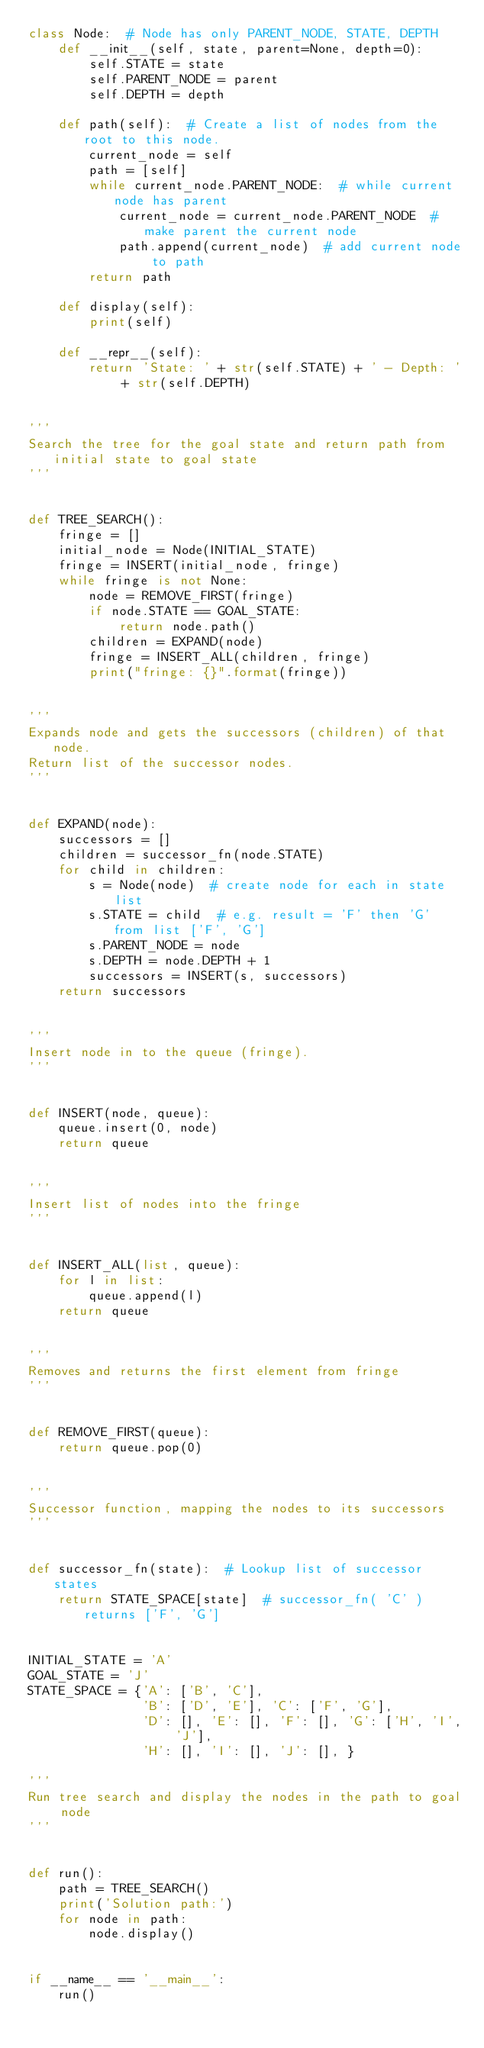Convert code to text. <code><loc_0><loc_0><loc_500><loc_500><_Python_>class Node:  # Node has only PARENT_NODE, STATE, DEPTH
    def __init__(self, state, parent=None, depth=0):
        self.STATE = state
        self.PARENT_NODE = parent
        self.DEPTH = depth

    def path(self):  # Create a list of nodes from the root to this node.
        current_node = self
        path = [self]
        while current_node.PARENT_NODE:  # while current node has parent
            current_node = current_node.PARENT_NODE  # make parent the current node
            path.append(current_node)  # add current node to path
        return path

    def display(self):
        print(self)

    def __repr__(self):
        return 'State: ' + str(self.STATE) + ' - Depth: ' + str(self.DEPTH)


'''
Search the tree for the goal state and return path from initial state to goal state
'''


def TREE_SEARCH():
    fringe = []
    initial_node = Node(INITIAL_STATE)
    fringe = INSERT(initial_node, fringe)
    while fringe is not None:
        node = REMOVE_FIRST(fringe)
        if node.STATE == GOAL_STATE:
            return node.path()
        children = EXPAND(node)
        fringe = INSERT_ALL(children, fringe)
        print("fringe: {}".format(fringe))


'''
Expands node and gets the successors (children) of that node.
Return list of the successor nodes.
'''


def EXPAND(node):
    successors = []
    children = successor_fn(node.STATE)
    for child in children:
        s = Node(node)  # create node for each in state list
        s.STATE = child  # e.g. result = 'F' then 'G' from list ['F', 'G']
        s.PARENT_NODE = node
        s.DEPTH = node.DEPTH + 1
        successors = INSERT(s, successors)
    return successors


'''
Insert node in to the queue (fringe).
'''


def INSERT(node, queue):
    queue.insert(0, node)
    return queue


'''
Insert list of nodes into the fringe
'''


def INSERT_ALL(list, queue):
    for l in list:
        queue.append(l)
    return queue


'''
Removes and returns the first element from fringe
'''


def REMOVE_FIRST(queue):
    return queue.pop(0)


'''
Successor function, mapping the nodes to its successors
'''


def successor_fn(state):  # Lookup list of successor states
    return STATE_SPACE[state]  # successor_fn( 'C' ) returns ['F', 'G']


INITIAL_STATE = 'A'
GOAL_STATE = 'J'
STATE_SPACE = {'A': ['B', 'C'],
               'B': ['D', 'E'], 'C': ['F', 'G'],
               'D': [], 'E': [], 'F': [], 'G': ['H', 'I', 'J'],
               'H': [], 'I': [], 'J': [], }

'''
Run tree search and display the nodes in the path to goal node
'''


def run():
    path = TREE_SEARCH()
    print('Solution path:')
    for node in path:
        node.display()


if __name__ == '__main__':
    run()
</code> 